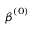Convert formula to latex. <formula><loc_0><loc_0><loc_500><loc_500>{ \beta } ^ { ( 0 ) }</formula> 